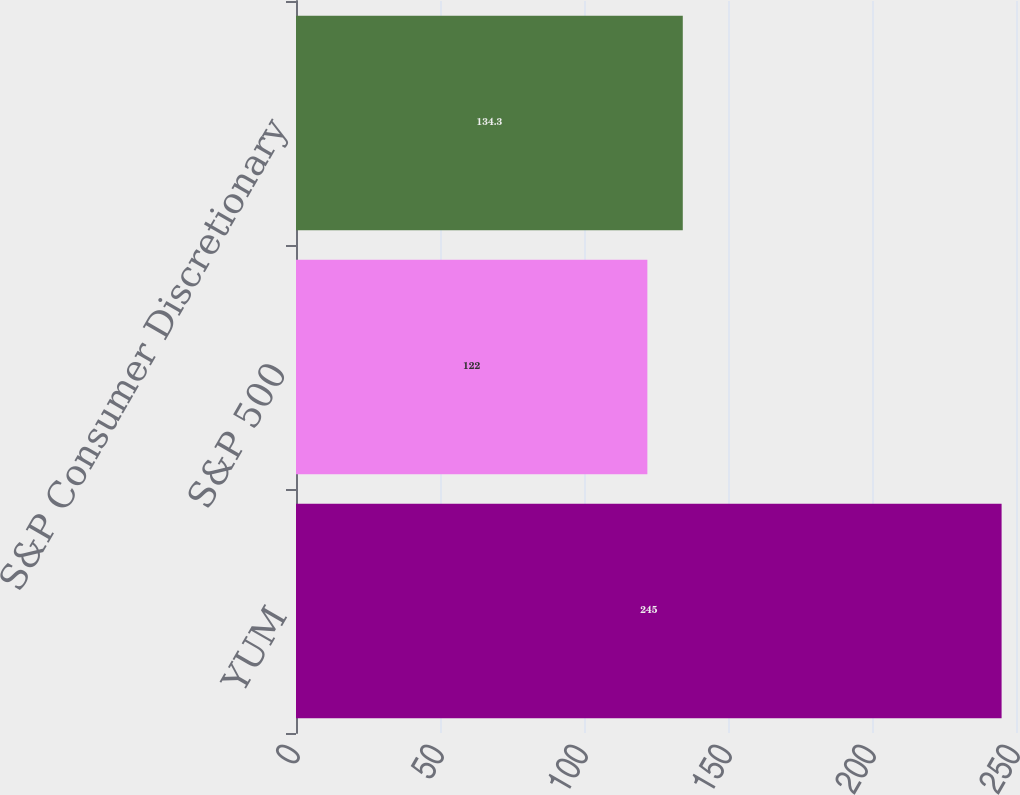Convert chart to OTSL. <chart><loc_0><loc_0><loc_500><loc_500><bar_chart><fcel>YUM<fcel>S&P 500<fcel>S&P Consumer Discretionary<nl><fcel>245<fcel>122<fcel>134.3<nl></chart> 